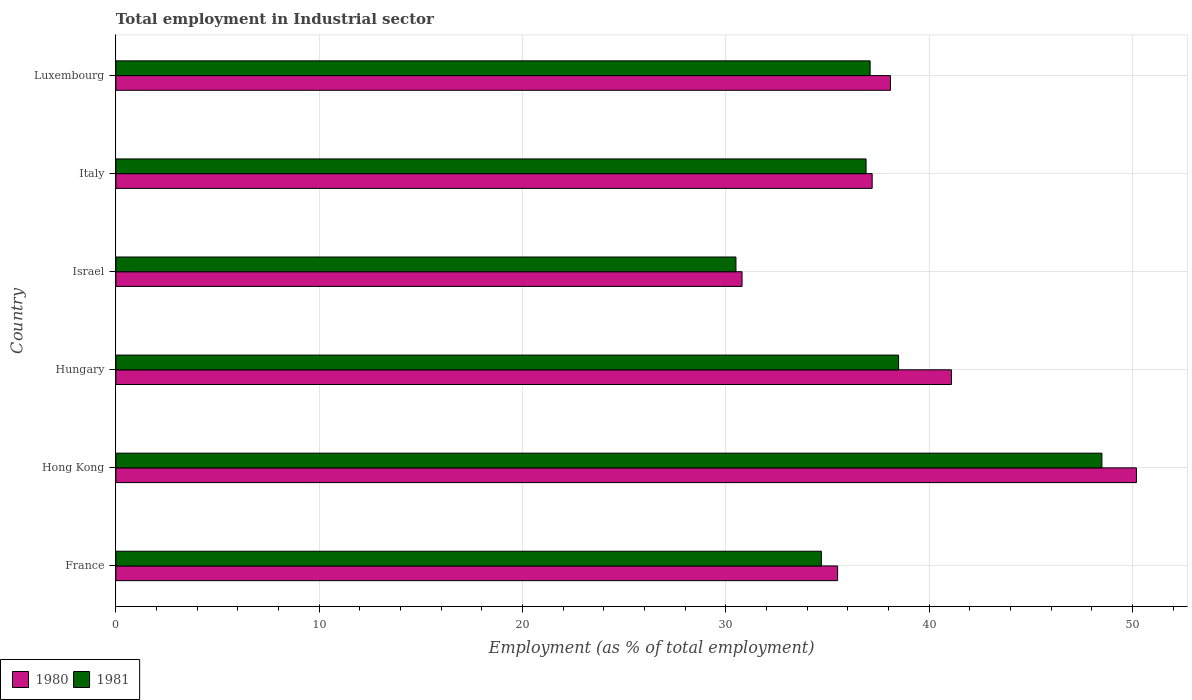How many groups of bars are there?
Your answer should be very brief. 6. Are the number of bars per tick equal to the number of legend labels?
Your answer should be compact. Yes. Are the number of bars on each tick of the Y-axis equal?
Your answer should be very brief. Yes. How many bars are there on the 3rd tick from the top?
Offer a very short reply. 2. What is the label of the 3rd group of bars from the top?
Give a very brief answer. Israel. In how many cases, is the number of bars for a given country not equal to the number of legend labels?
Make the answer very short. 0. What is the employment in industrial sector in 1981 in Israel?
Offer a very short reply. 30.5. Across all countries, what is the maximum employment in industrial sector in 1980?
Make the answer very short. 50.2. Across all countries, what is the minimum employment in industrial sector in 1980?
Your answer should be very brief. 30.8. In which country was the employment in industrial sector in 1981 maximum?
Offer a very short reply. Hong Kong. What is the total employment in industrial sector in 1981 in the graph?
Give a very brief answer. 226.2. What is the difference between the employment in industrial sector in 1980 in Hungary and that in Italy?
Ensure brevity in your answer.  3.9. What is the difference between the employment in industrial sector in 1981 in Italy and the employment in industrial sector in 1980 in France?
Your response must be concise. 1.4. What is the average employment in industrial sector in 1981 per country?
Provide a succinct answer. 37.7. What is the difference between the employment in industrial sector in 1980 and employment in industrial sector in 1981 in France?
Your response must be concise. 0.8. In how many countries, is the employment in industrial sector in 1981 greater than 26 %?
Give a very brief answer. 6. What is the ratio of the employment in industrial sector in 1981 in Hong Kong to that in Israel?
Ensure brevity in your answer.  1.59. Is the employment in industrial sector in 1981 in France less than that in Luxembourg?
Make the answer very short. Yes. What is the difference between the highest and the lowest employment in industrial sector in 1980?
Offer a terse response. 19.4. In how many countries, is the employment in industrial sector in 1981 greater than the average employment in industrial sector in 1981 taken over all countries?
Your response must be concise. 2. Is the sum of the employment in industrial sector in 1981 in France and Hungary greater than the maximum employment in industrial sector in 1980 across all countries?
Your response must be concise. Yes. What does the 1st bar from the bottom in Hungary represents?
Provide a short and direct response. 1980. How many bars are there?
Provide a succinct answer. 12. Are all the bars in the graph horizontal?
Your answer should be very brief. Yes. How many countries are there in the graph?
Keep it short and to the point. 6. How many legend labels are there?
Keep it short and to the point. 2. How are the legend labels stacked?
Keep it short and to the point. Horizontal. What is the title of the graph?
Your answer should be very brief. Total employment in Industrial sector. What is the label or title of the X-axis?
Offer a terse response. Employment (as % of total employment). What is the label or title of the Y-axis?
Ensure brevity in your answer.  Country. What is the Employment (as % of total employment) of 1980 in France?
Make the answer very short. 35.5. What is the Employment (as % of total employment) of 1981 in France?
Your response must be concise. 34.7. What is the Employment (as % of total employment) in 1980 in Hong Kong?
Make the answer very short. 50.2. What is the Employment (as % of total employment) of 1981 in Hong Kong?
Ensure brevity in your answer.  48.5. What is the Employment (as % of total employment) of 1980 in Hungary?
Offer a terse response. 41.1. What is the Employment (as % of total employment) of 1981 in Hungary?
Your response must be concise. 38.5. What is the Employment (as % of total employment) of 1980 in Israel?
Offer a very short reply. 30.8. What is the Employment (as % of total employment) in 1981 in Israel?
Offer a terse response. 30.5. What is the Employment (as % of total employment) in 1980 in Italy?
Offer a terse response. 37.2. What is the Employment (as % of total employment) of 1981 in Italy?
Provide a short and direct response. 36.9. What is the Employment (as % of total employment) in 1980 in Luxembourg?
Your answer should be very brief. 38.1. What is the Employment (as % of total employment) in 1981 in Luxembourg?
Your response must be concise. 37.1. Across all countries, what is the maximum Employment (as % of total employment) in 1980?
Offer a very short reply. 50.2. Across all countries, what is the maximum Employment (as % of total employment) in 1981?
Provide a succinct answer. 48.5. Across all countries, what is the minimum Employment (as % of total employment) of 1980?
Provide a short and direct response. 30.8. Across all countries, what is the minimum Employment (as % of total employment) in 1981?
Provide a short and direct response. 30.5. What is the total Employment (as % of total employment) of 1980 in the graph?
Offer a very short reply. 232.9. What is the total Employment (as % of total employment) in 1981 in the graph?
Your answer should be compact. 226.2. What is the difference between the Employment (as % of total employment) of 1980 in France and that in Hong Kong?
Keep it short and to the point. -14.7. What is the difference between the Employment (as % of total employment) in 1981 in France and that in Hungary?
Your answer should be very brief. -3.8. What is the difference between the Employment (as % of total employment) of 1980 in France and that in Italy?
Make the answer very short. -1.7. What is the difference between the Employment (as % of total employment) of 1981 in France and that in Luxembourg?
Ensure brevity in your answer.  -2.4. What is the difference between the Employment (as % of total employment) in 1980 in Hong Kong and that in Hungary?
Ensure brevity in your answer.  9.1. What is the difference between the Employment (as % of total employment) in 1981 in Hong Kong and that in Israel?
Your answer should be compact. 18. What is the difference between the Employment (as % of total employment) in 1981 in Hong Kong and that in Luxembourg?
Your answer should be very brief. 11.4. What is the difference between the Employment (as % of total employment) in 1980 in Hungary and that in Israel?
Make the answer very short. 10.3. What is the difference between the Employment (as % of total employment) in 1981 in Hungary and that in Israel?
Your response must be concise. 8. What is the difference between the Employment (as % of total employment) of 1980 in Hungary and that in Luxembourg?
Your answer should be compact. 3. What is the difference between the Employment (as % of total employment) of 1980 in Israel and that in Italy?
Ensure brevity in your answer.  -6.4. What is the difference between the Employment (as % of total employment) in 1981 in Israel and that in Italy?
Ensure brevity in your answer.  -6.4. What is the difference between the Employment (as % of total employment) of 1981 in Israel and that in Luxembourg?
Provide a succinct answer. -6.6. What is the difference between the Employment (as % of total employment) of 1980 in France and the Employment (as % of total employment) of 1981 in Hong Kong?
Keep it short and to the point. -13. What is the difference between the Employment (as % of total employment) of 1980 in France and the Employment (as % of total employment) of 1981 in Hungary?
Offer a very short reply. -3. What is the difference between the Employment (as % of total employment) of 1980 in France and the Employment (as % of total employment) of 1981 in Italy?
Provide a succinct answer. -1.4. What is the difference between the Employment (as % of total employment) of 1980 in France and the Employment (as % of total employment) of 1981 in Luxembourg?
Make the answer very short. -1.6. What is the difference between the Employment (as % of total employment) of 1980 in Hong Kong and the Employment (as % of total employment) of 1981 in Hungary?
Ensure brevity in your answer.  11.7. What is the difference between the Employment (as % of total employment) in 1980 in Hungary and the Employment (as % of total employment) in 1981 in Israel?
Your answer should be compact. 10.6. What is the difference between the Employment (as % of total employment) of 1980 in Hungary and the Employment (as % of total employment) of 1981 in Italy?
Your answer should be compact. 4.2. What is the difference between the Employment (as % of total employment) of 1980 in Hungary and the Employment (as % of total employment) of 1981 in Luxembourg?
Provide a succinct answer. 4. What is the average Employment (as % of total employment) in 1980 per country?
Your answer should be very brief. 38.82. What is the average Employment (as % of total employment) in 1981 per country?
Your response must be concise. 37.7. What is the difference between the Employment (as % of total employment) of 1980 and Employment (as % of total employment) of 1981 in Luxembourg?
Provide a short and direct response. 1. What is the ratio of the Employment (as % of total employment) in 1980 in France to that in Hong Kong?
Provide a succinct answer. 0.71. What is the ratio of the Employment (as % of total employment) of 1981 in France to that in Hong Kong?
Make the answer very short. 0.72. What is the ratio of the Employment (as % of total employment) in 1980 in France to that in Hungary?
Offer a terse response. 0.86. What is the ratio of the Employment (as % of total employment) of 1981 in France to that in Hungary?
Your answer should be compact. 0.9. What is the ratio of the Employment (as % of total employment) in 1980 in France to that in Israel?
Your answer should be very brief. 1.15. What is the ratio of the Employment (as % of total employment) of 1981 in France to that in Israel?
Ensure brevity in your answer.  1.14. What is the ratio of the Employment (as % of total employment) of 1980 in France to that in Italy?
Keep it short and to the point. 0.95. What is the ratio of the Employment (as % of total employment) in 1981 in France to that in Italy?
Your response must be concise. 0.94. What is the ratio of the Employment (as % of total employment) of 1980 in France to that in Luxembourg?
Keep it short and to the point. 0.93. What is the ratio of the Employment (as % of total employment) of 1981 in France to that in Luxembourg?
Your response must be concise. 0.94. What is the ratio of the Employment (as % of total employment) in 1980 in Hong Kong to that in Hungary?
Make the answer very short. 1.22. What is the ratio of the Employment (as % of total employment) in 1981 in Hong Kong to that in Hungary?
Offer a terse response. 1.26. What is the ratio of the Employment (as % of total employment) of 1980 in Hong Kong to that in Israel?
Your response must be concise. 1.63. What is the ratio of the Employment (as % of total employment) in 1981 in Hong Kong to that in Israel?
Keep it short and to the point. 1.59. What is the ratio of the Employment (as % of total employment) in 1980 in Hong Kong to that in Italy?
Keep it short and to the point. 1.35. What is the ratio of the Employment (as % of total employment) in 1981 in Hong Kong to that in Italy?
Your answer should be compact. 1.31. What is the ratio of the Employment (as % of total employment) in 1980 in Hong Kong to that in Luxembourg?
Your answer should be very brief. 1.32. What is the ratio of the Employment (as % of total employment) of 1981 in Hong Kong to that in Luxembourg?
Your answer should be very brief. 1.31. What is the ratio of the Employment (as % of total employment) in 1980 in Hungary to that in Israel?
Give a very brief answer. 1.33. What is the ratio of the Employment (as % of total employment) in 1981 in Hungary to that in Israel?
Make the answer very short. 1.26. What is the ratio of the Employment (as % of total employment) of 1980 in Hungary to that in Italy?
Your answer should be very brief. 1.1. What is the ratio of the Employment (as % of total employment) in 1981 in Hungary to that in Italy?
Make the answer very short. 1.04. What is the ratio of the Employment (as % of total employment) of 1980 in Hungary to that in Luxembourg?
Offer a very short reply. 1.08. What is the ratio of the Employment (as % of total employment) in 1981 in Hungary to that in Luxembourg?
Ensure brevity in your answer.  1.04. What is the ratio of the Employment (as % of total employment) of 1980 in Israel to that in Italy?
Keep it short and to the point. 0.83. What is the ratio of the Employment (as % of total employment) in 1981 in Israel to that in Italy?
Offer a terse response. 0.83. What is the ratio of the Employment (as % of total employment) of 1980 in Israel to that in Luxembourg?
Your answer should be very brief. 0.81. What is the ratio of the Employment (as % of total employment) of 1981 in Israel to that in Luxembourg?
Your answer should be very brief. 0.82. What is the ratio of the Employment (as % of total employment) of 1980 in Italy to that in Luxembourg?
Your answer should be compact. 0.98. What is the difference between the highest and the lowest Employment (as % of total employment) in 1980?
Offer a terse response. 19.4. 